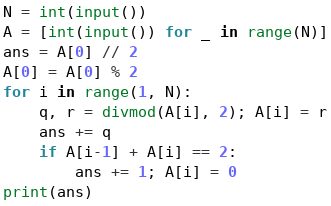<code> <loc_0><loc_0><loc_500><loc_500><_Python_>N = int(input())
A = [int(input()) for _ in range(N)]
ans = A[0] // 2
A[0] = A[0] % 2
for i in range(1, N):
    q, r = divmod(A[i], 2); A[i] = r
    ans += q
    if A[i-1] + A[i] == 2:
        ans += 1; A[i] = 0
print(ans)</code> 